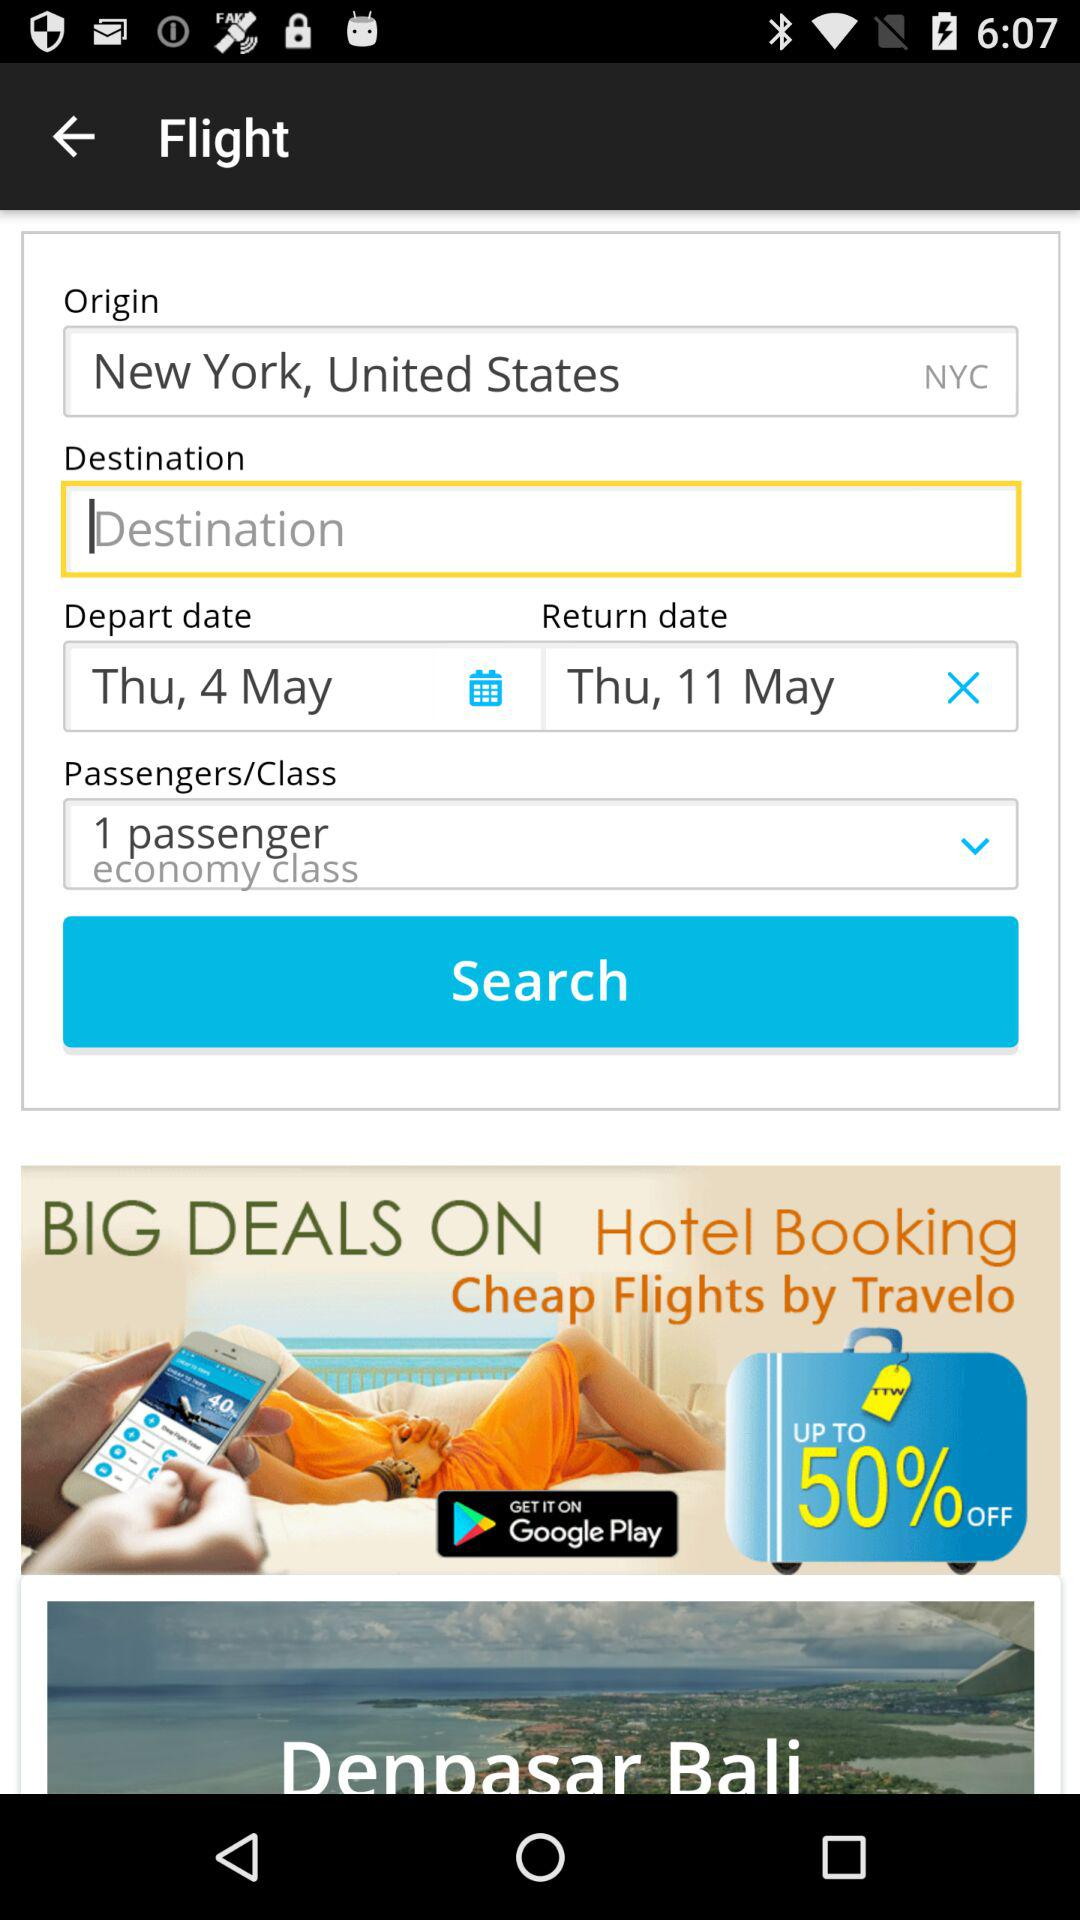What is the departure date? The departure date is Thursday, May 4. 